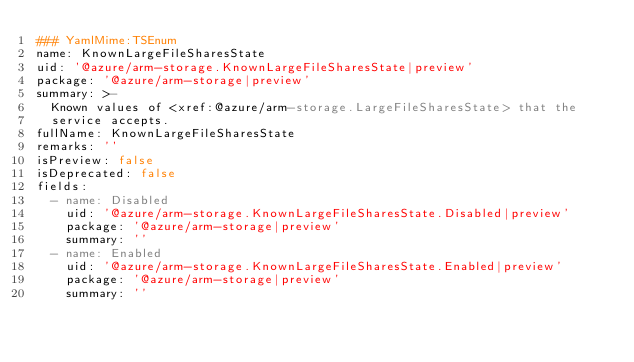<code> <loc_0><loc_0><loc_500><loc_500><_YAML_>### YamlMime:TSEnum
name: KnownLargeFileSharesState
uid: '@azure/arm-storage.KnownLargeFileSharesState|preview'
package: '@azure/arm-storage|preview'
summary: >-
  Known values of <xref:@azure/arm-storage.LargeFileSharesState> that the
  service accepts.
fullName: KnownLargeFileSharesState
remarks: ''
isPreview: false
isDeprecated: false
fields:
  - name: Disabled
    uid: '@azure/arm-storage.KnownLargeFileSharesState.Disabled|preview'
    package: '@azure/arm-storage|preview'
    summary: ''
  - name: Enabled
    uid: '@azure/arm-storage.KnownLargeFileSharesState.Enabled|preview'
    package: '@azure/arm-storage|preview'
    summary: ''
</code> 